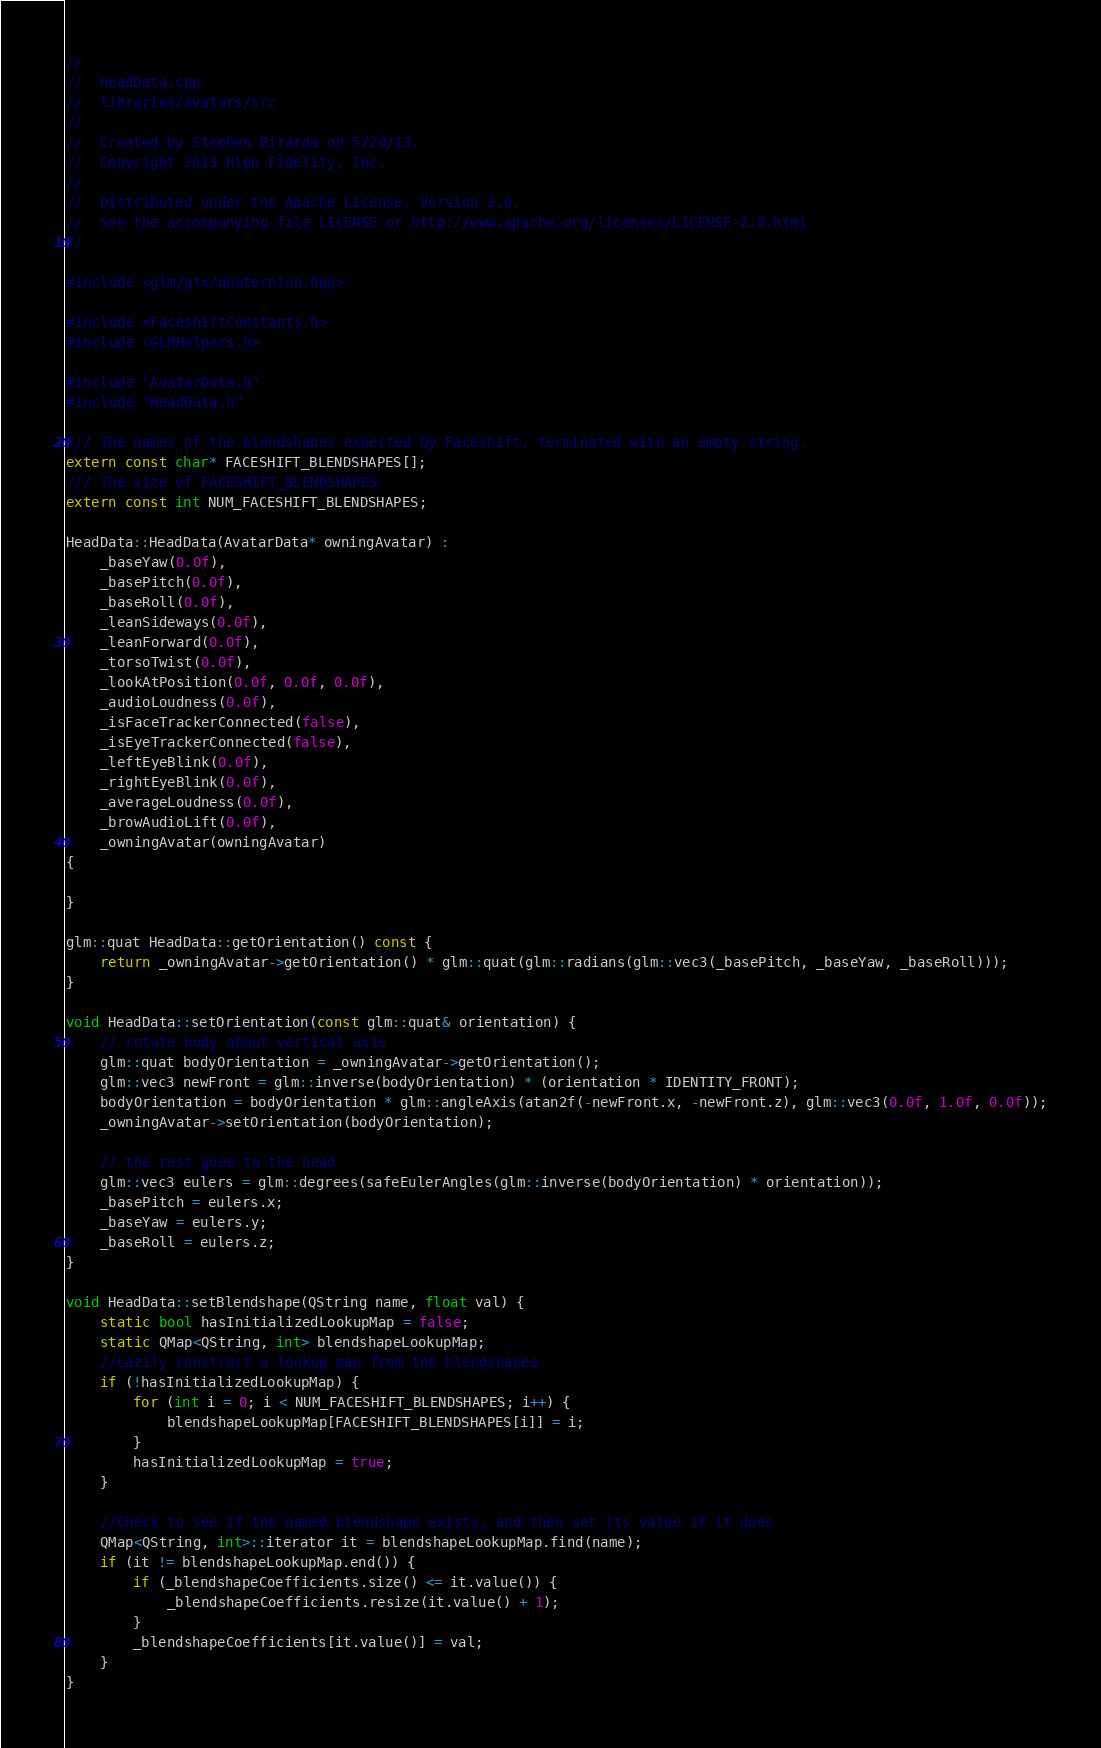<code> <loc_0><loc_0><loc_500><loc_500><_C++_>//
//  HeadData.cpp
//  libraries/avatars/src
//
//  Created by Stephen Birarda on 5/20/13.
//  Copyright 2013 High Fidelity, Inc.
//
//  Distributed under the Apache License, Version 2.0.
//  See the accompanying file LICENSE or http://www.apache.org/licenses/LICENSE-2.0.html
//

#include <glm/gtx/quaternion.hpp>

#include <FaceshiftConstants.h>
#include <GLMHelpers.h>

#include "AvatarData.h"
#include "HeadData.h"

/// The names of the blendshapes expected by Faceshift, terminated with an empty string.
extern const char* FACESHIFT_BLENDSHAPES[];
/// The size of FACESHIFT_BLENDSHAPES
extern const int NUM_FACESHIFT_BLENDSHAPES;

HeadData::HeadData(AvatarData* owningAvatar) :
    _baseYaw(0.0f),
    _basePitch(0.0f),
    _baseRoll(0.0f),
    _leanSideways(0.0f),
    _leanForward(0.0f),
    _torsoTwist(0.0f),
    _lookAtPosition(0.0f, 0.0f, 0.0f),
    _audioLoudness(0.0f),
    _isFaceTrackerConnected(false),
    _isEyeTrackerConnected(false),
    _leftEyeBlink(0.0f),
    _rightEyeBlink(0.0f),
    _averageLoudness(0.0f),
    _browAudioLift(0.0f),
    _owningAvatar(owningAvatar)
{
    
}

glm::quat HeadData::getOrientation() const {
    return _owningAvatar->getOrientation() * glm::quat(glm::radians(glm::vec3(_basePitch, _baseYaw, _baseRoll)));
}

void HeadData::setOrientation(const glm::quat& orientation) {
    // rotate body about vertical axis
    glm::quat bodyOrientation = _owningAvatar->getOrientation();
    glm::vec3 newFront = glm::inverse(bodyOrientation) * (orientation * IDENTITY_FRONT);
    bodyOrientation = bodyOrientation * glm::angleAxis(atan2f(-newFront.x, -newFront.z), glm::vec3(0.0f, 1.0f, 0.0f));
    _owningAvatar->setOrientation(bodyOrientation);
    
    // the rest goes to the head
    glm::vec3 eulers = glm::degrees(safeEulerAngles(glm::inverse(bodyOrientation) * orientation));
    _basePitch = eulers.x;
    _baseYaw = eulers.y;
    _baseRoll = eulers.z;
}

void HeadData::setBlendshape(QString name, float val) {
    static bool hasInitializedLookupMap = false;
    static QMap<QString, int> blendshapeLookupMap;
    //Lazily construct a lookup map from the blendshapes
    if (!hasInitializedLookupMap) {
        for (int i = 0; i < NUM_FACESHIFT_BLENDSHAPES; i++) {
            blendshapeLookupMap[FACESHIFT_BLENDSHAPES[i]] = i; 
        }
        hasInitializedLookupMap = true;
    }

    //Check to see if the named blendshape exists, and then set its value if it does
    QMap<QString, int>::iterator it = blendshapeLookupMap.find(name);
    if (it != blendshapeLookupMap.end()) {
        if (_blendshapeCoefficients.size() <= it.value()) {
            _blendshapeCoefficients.resize(it.value() + 1);
        }
        _blendshapeCoefficients[it.value()] = val;
    }
}
</code> 